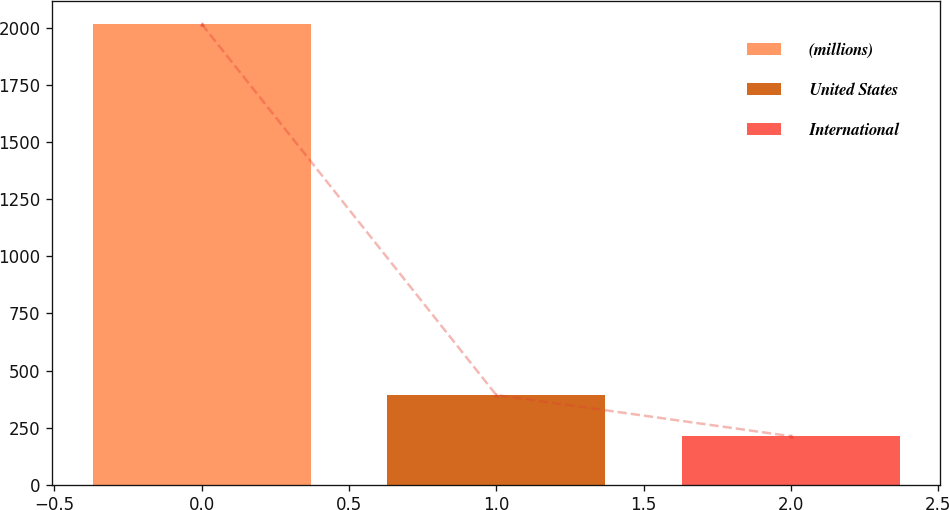<chart> <loc_0><loc_0><loc_500><loc_500><bar_chart><fcel>(millions)<fcel>United States<fcel>International<nl><fcel>2017<fcel>393.13<fcel>212.7<nl></chart> 